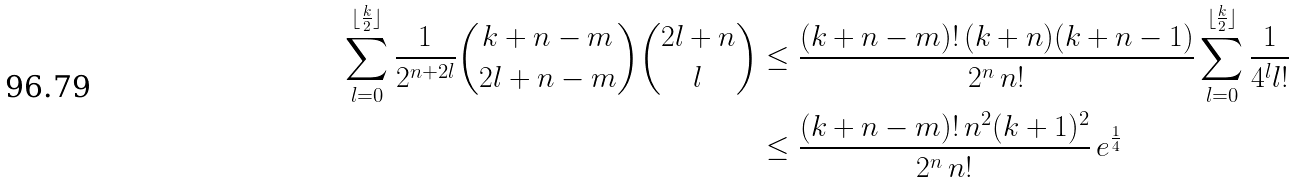Convert formula to latex. <formula><loc_0><loc_0><loc_500><loc_500>\sum _ { l = 0 } ^ { \lfloor \frac { k } { 2 } \rfloor } { \frac { 1 } { 2 ^ { n + 2 l } } \binom { k + n - m } { 2 l + n - m } \binom { 2 l + n } { l } } & \leq \frac { ( k + n - m ) ! \, ( k + n ) ( k + n - 1 ) } { 2 ^ { n } \, n ! } \sum _ { l = 0 } ^ { \lfloor \frac { k } { 2 } \rfloor } \frac { 1 } { 4 ^ { l } l ! } \\ & \leq \frac { ( k + n - m ) ! \, n ^ { 2 } ( k + 1 ) ^ { 2 } } { 2 ^ { n } \, n ! } \, e ^ { \frac { 1 } { 4 } }</formula> 